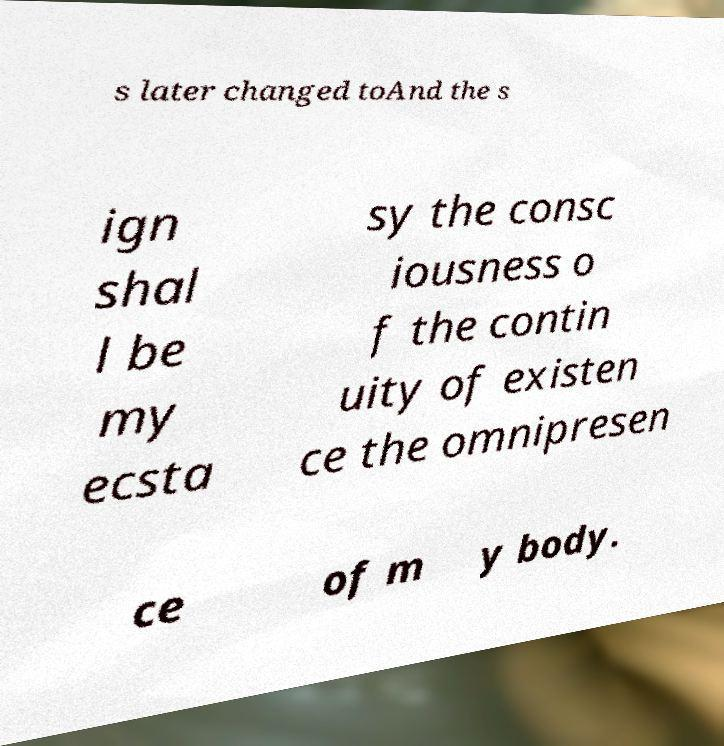Please read and relay the text visible in this image. What does it say? s later changed toAnd the s ign shal l be my ecsta sy the consc iousness o f the contin uity of existen ce the omnipresen ce of m y body. 